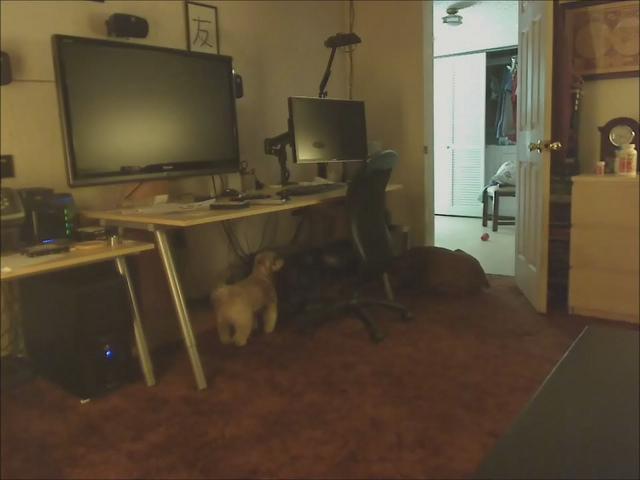The thing that is under the desk belongs to what family?
From the following set of four choices, select the accurate answer to respond to the question.
Options: Canidae, addams, partridge, bovidae. Canidae. 